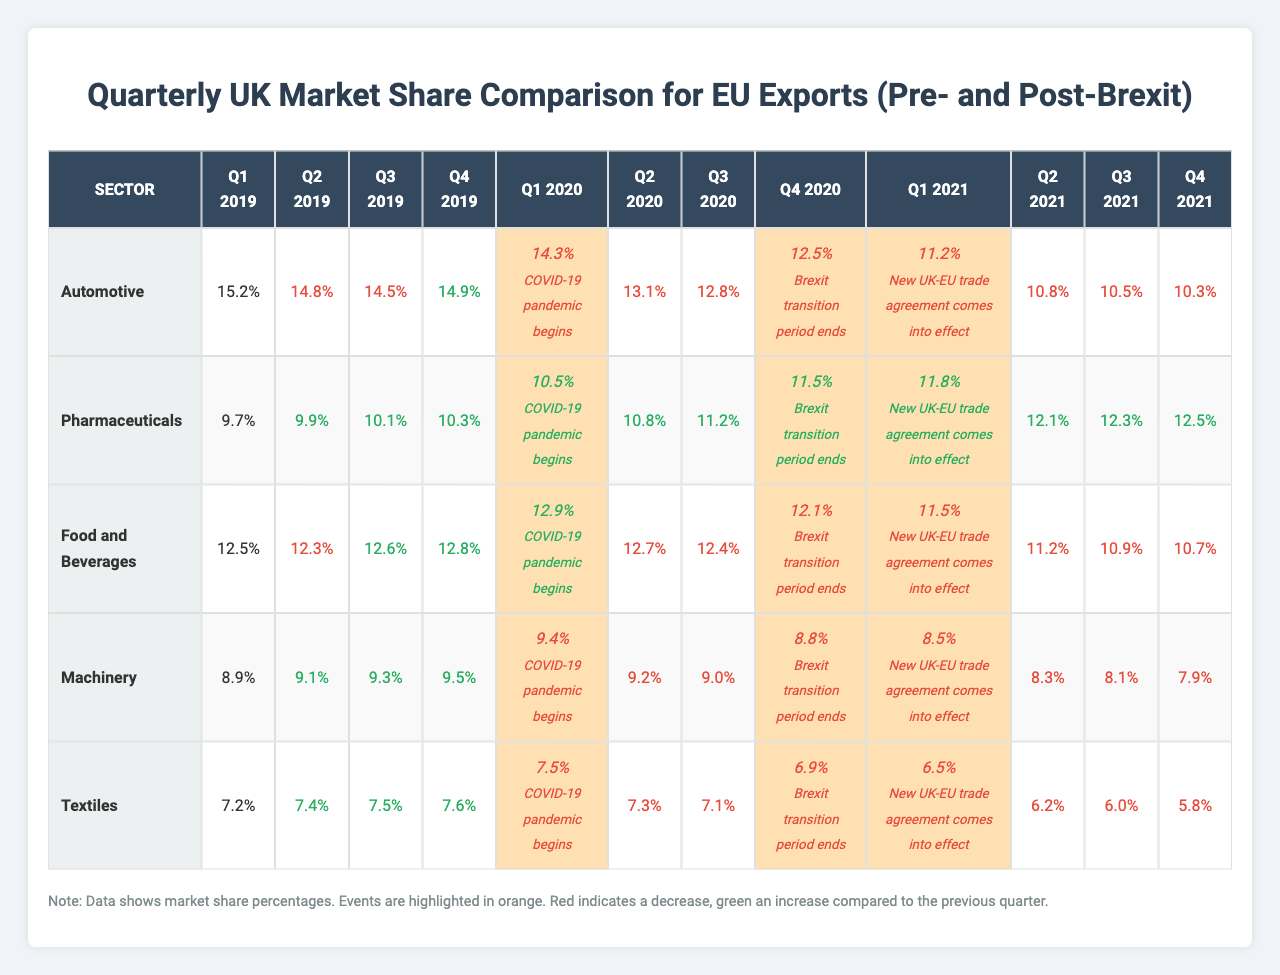What was the market share of the Pharmaceuticals sector in Q4 2021? From the table, the market share for Pharmaceuticals in Q4 2021 is 12.5%.
Answer: 12.5% What event occurred in Q4 2020 that impacted market shares? The table indicates that the Brexit transition period ended in Q4 2020, which is a significant event for EU exports to the UK.
Answer: Brexit transition period ends Which sector had the highest market share in Q1 2019? According to the table, the Automotive sector had the highest market share at 15.2% in Q1 2019.
Answer: Automotive Did the market share for Textiles increase or decrease from Q1 2020 to Q1 2021? The market share for Textiles decreased from 7.5% in Q1 2020 to 6.5% in Q1 2021. A comparison of these two values shows a decrease.
Answer: Decrease What was the overall trend for the Automotive sector from Q1 2019 to Q2 2021? The market share for the Automotive sector declined from 15.2% in Q1 2019 to 10.8% in Q2 2021, indicating a downward trend over this period.
Answer: Downward trend What was the percentage drop in market share for Food and Beverages from Q1 2020 to Q4 2020? The market share for Food and Beverages decreased from 12.9% in Q1 2020 to 12.1% in Q4 2020, resulting in a drop of 0.8%.
Answer: 0.8% drop Which sector experienced the largest percentage decline between Q1 2020 and Q1 2021? By comparing the quarter values, the Automotive sector saw the largest decline, from 14.3% in Q1 2020 to 11.2% in Q1 2021, which is a 3.1% decrease.
Answer: Automotive sector, 3.1% decline What was the average market share for Pharmaceuticals in the second quarter of each year listed? The market shares for Pharmaceuticals in Q2 of each year are 9.9% (2019), 10.8% (2020), 12.1% (2021). Summing these gives 32.8% and dividing by 3 gives an average of 10.93%.
Answer: 10.93% Did the market share for Machinery increase from Q4 2020 to Q1 2021? In the table, Machinery's market share was 8.8% in Q4 2020 and decreased to 8.5% in Q1 2021, confirming a decrease rather than an increase.
Answer: No Which top EU exporter had the lowest market share for Textiles in Q4 2021? In Q4 2021, the table shows that the Textiles sector had a market share of 5.8%, which is the lowest among the sectors listed.
Answer: 5.8% in Textiles What was the change in the market share of Food and Beverages from Q3 2021 to Q4 2021? Food and Beverages showed a decrease from 10.9% in Q3 2021 to 10.7% in Q4 2021, indicating a change of -0.2%.
Answer: -0.2% decrease 